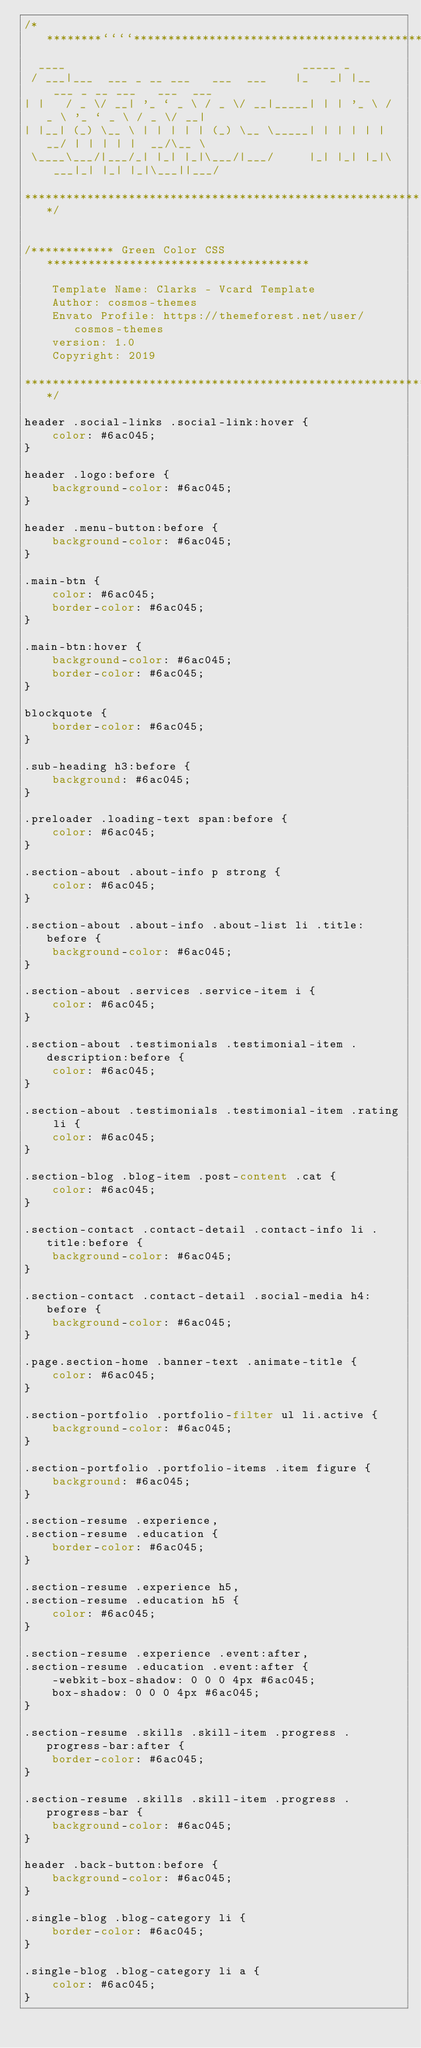<code> <loc_0><loc_0><loc_500><loc_500><_CSS_>/*********````********************************************************************
  ____                                  _____ _
 / ___|___  ___ _ __ ___   ___  ___    |_   _| |__   ___ _ __ ___   ___  ___
| |   / _ \/ __| '_ ` _ \ / _ \/ __|_____| | | '_ \ / _ \ '_ ` _ \ / _ \/ __|
| |__| (_) \__ \ | | | | | (_) \__ \_____| | | | | |  __/ | | | | |  __/\__ \
 \____\___/|___/_| |_| |_|\___/|___/     |_| |_| |_|\___|_| |_| |_|\___||___/

******************************************************************************/


/************ Green Color CSS  **************************************

    Template Name: Clarks - Vcard Template
    Author: cosmos-themes
    Envato Profile: https://themeforest.net/user/cosmos-themes
    version: 1.0
    Copyright: 2019

****************************************************************/

header .social-links .social-link:hover {
    color: #6ac045;
}

header .logo:before {
    background-color: #6ac045;
}

header .menu-button:before {
    background-color: #6ac045;
}

.main-btn {
    color: #6ac045;
    border-color: #6ac045;
}

.main-btn:hover {
    background-color: #6ac045;
    border-color: #6ac045;
}

blockquote {
    border-color: #6ac045;
}

.sub-heading h3:before {
    background: #6ac045;
}

.preloader .loading-text span:before {
    color: #6ac045;
}

.section-about .about-info p strong {
    color: #6ac045;
}

.section-about .about-info .about-list li .title:before {
    background-color: #6ac045;
}

.section-about .services .service-item i {
    color: #6ac045;
}

.section-about .testimonials .testimonial-item .description:before {
    color: #6ac045;
}

.section-about .testimonials .testimonial-item .rating li {
    color: #6ac045;
}

.section-blog .blog-item .post-content .cat {
    color: #6ac045;
}

.section-contact .contact-detail .contact-info li .title:before {
    background-color: #6ac045;
}

.section-contact .contact-detail .social-media h4:before {
    background-color: #6ac045;
}

.page.section-home .banner-text .animate-title {
    color: #6ac045;
}

.section-portfolio .portfolio-filter ul li.active {
    background-color: #6ac045;
}

.section-portfolio .portfolio-items .item figure {
    background: #6ac045;
}

.section-resume .experience,
.section-resume .education {
    border-color: #6ac045;
}

.section-resume .experience h5,
.section-resume .education h5 {
    color: #6ac045;
}

.section-resume .experience .event:after,
.section-resume .education .event:after {
    -webkit-box-shadow: 0 0 0 4px #6ac045;
    box-shadow: 0 0 0 4px #6ac045;
}

.section-resume .skills .skill-item .progress .progress-bar:after {
    border-color: #6ac045;
}

.section-resume .skills .skill-item .progress .progress-bar {
    background-color: #6ac045;
}

header .back-button:before {
    background-color: #6ac045;
}

.single-blog .blog-category li {
    border-color: #6ac045;
}

.single-blog .blog-category li a {
    color: #6ac045;
}</code> 